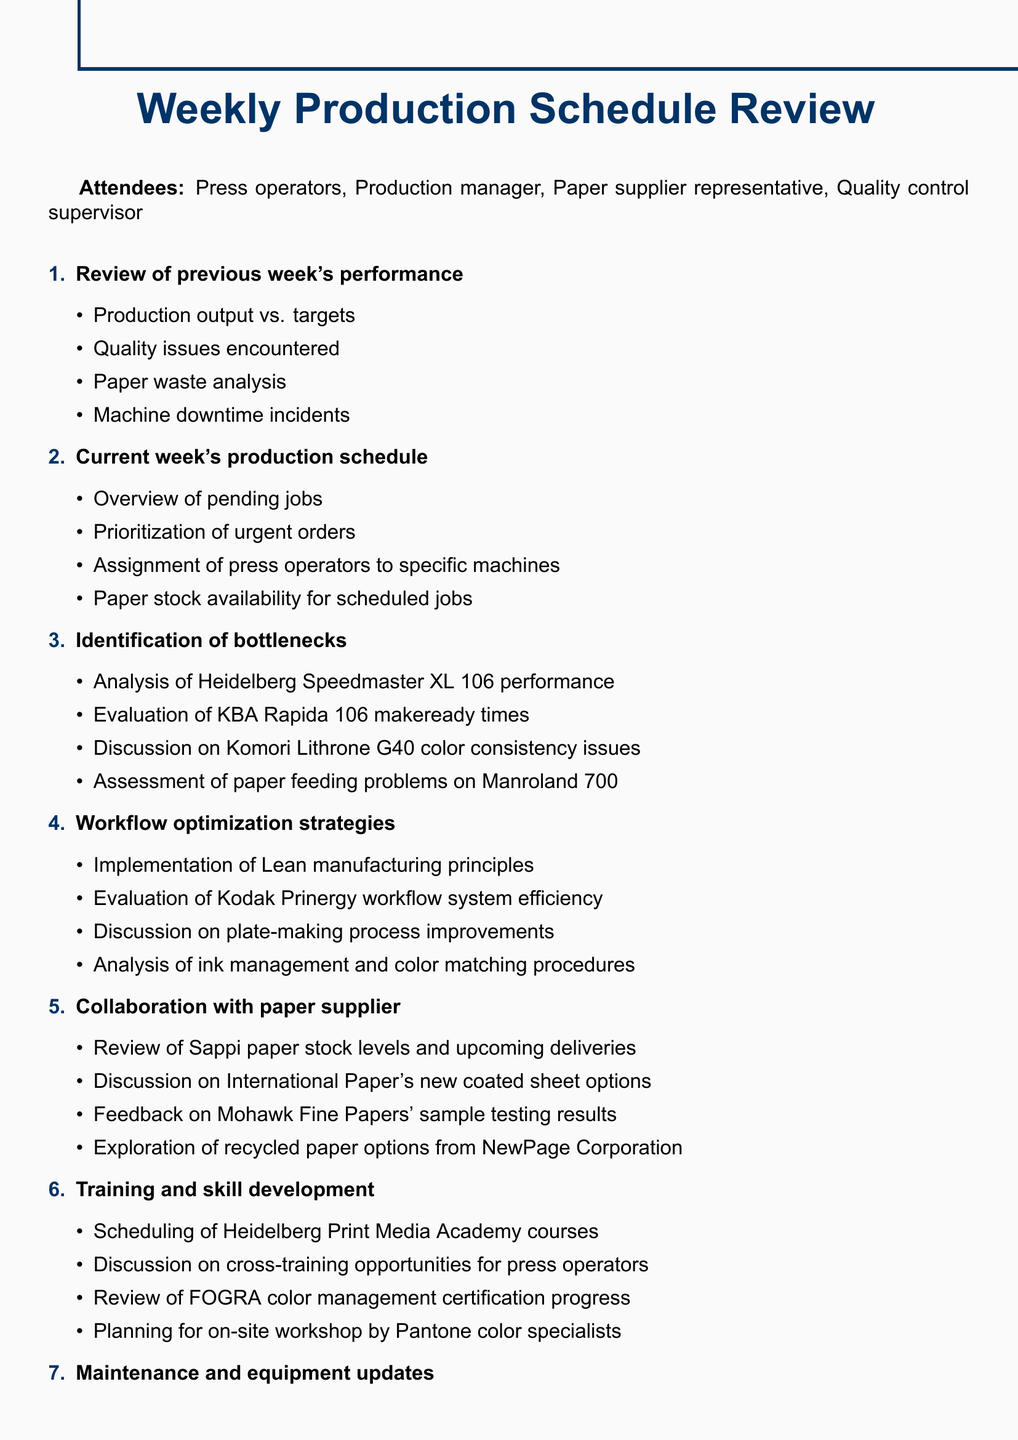What is the title of the meeting? The title of the meeting is stated at the beginning of the document.
Answer: Weekly Production Schedule Review Who are the attendees? The list of attendees is provided in the document, listed together.
Answer: Press operators, Production manager, Paper supplier representative, Quality control supervisor What is one key performance indicator mentioned? Key performance indicators are listed towards the end of the document, and one example is requested.
Answer: On-time delivery rate How many agenda items are there? The number of agenda items can be counted from the structure of the document.
Answer: Eight What is one topic discussed under "Identification of bottlenecks"? The document lists specific topics under this agenda item, and one can be cited.
Answer: Analysis of Heidelberg Speedmaster XL 106 performance What is mentioned about training opportunities? The "Training and skill development" section provides details on this topic.
Answer: Cross-training opportunities for press operators What maintenance is scheduled for the Muller Martini stitching line? The agenda item provides specific maintenance-related actions.
Answer: Preventive maintenance What are the follow-up actions specified? The final section outlines actions and responsibilities for follow-up.
Answer: Assignment of responsibilities for identified improvements 